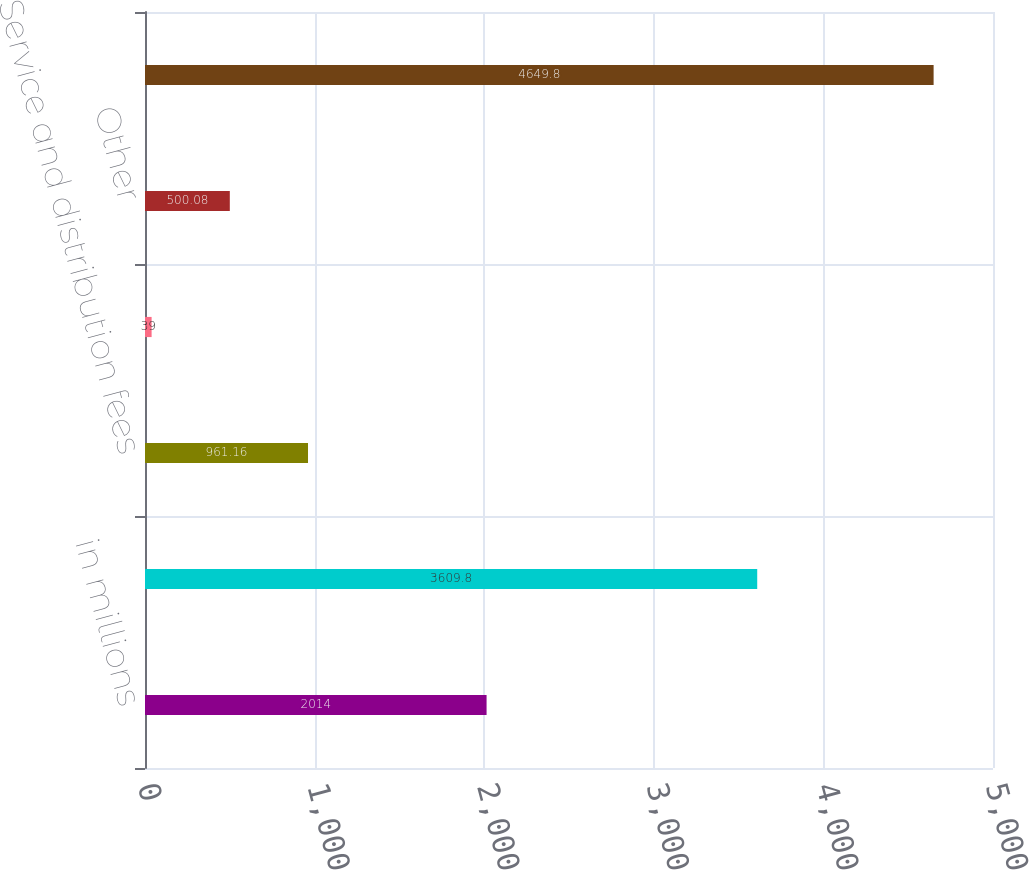<chart> <loc_0><loc_0><loc_500><loc_500><bar_chart><fcel>in millions<fcel>Investment management fees<fcel>Service and distribution fees<fcel>Performance fees<fcel>Other<fcel>Total affiliated operating<nl><fcel>2014<fcel>3609.8<fcel>961.16<fcel>39<fcel>500.08<fcel>4649.8<nl></chart> 